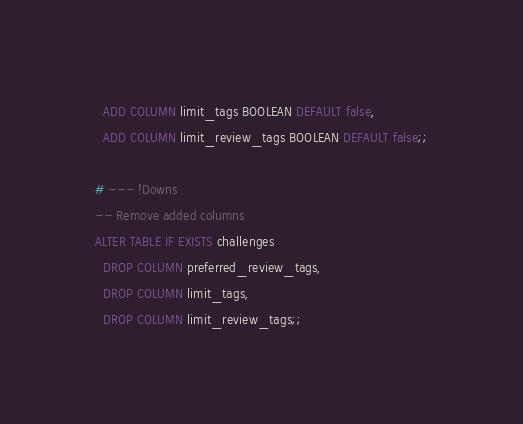Convert code to text. <code><loc_0><loc_0><loc_500><loc_500><_SQL_>  ADD COLUMN limit_tags BOOLEAN DEFAULT false,
  ADD COLUMN limit_review_tags BOOLEAN DEFAULT false;;

# --- !Downs
-- Remove added columns
ALTER TABLE IF EXISTS challenges
  DROP COLUMN preferred_review_tags,
  DROP COLUMN limit_tags,
  DROP COLUMN limit_review_tags;;
</code> 